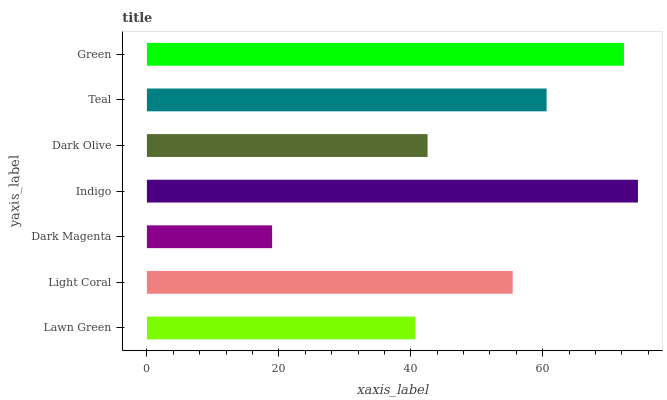Is Dark Magenta the minimum?
Answer yes or no. Yes. Is Indigo the maximum?
Answer yes or no. Yes. Is Light Coral the minimum?
Answer yes or no. No. Is Light Coral the maximum?
Answer yes or no. No. Is Light Coral greater than Lawn Green?
Answer yes or no. Yes. Is Lawn Green less than Light Coral?
Answer yes or no. Yes. Is Lawn Green greater than Light Coral?
Answer yes or no. No. Is Light Coral less than Lawn Green?
Answer yes or no. No. Is Light Coral the high median?
Answer yes or no. Yes. Is Light Coral the low median?
Answer yes or no. Yes. Is Indigo the high median?
Answer yes or no. No. Is Indigo the low median?
Answer yes or no. No. 